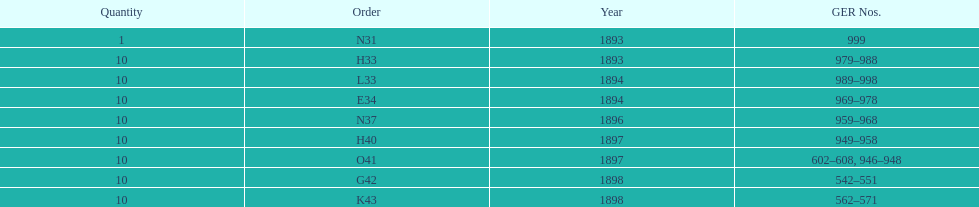What is the last year listed? 1898. 